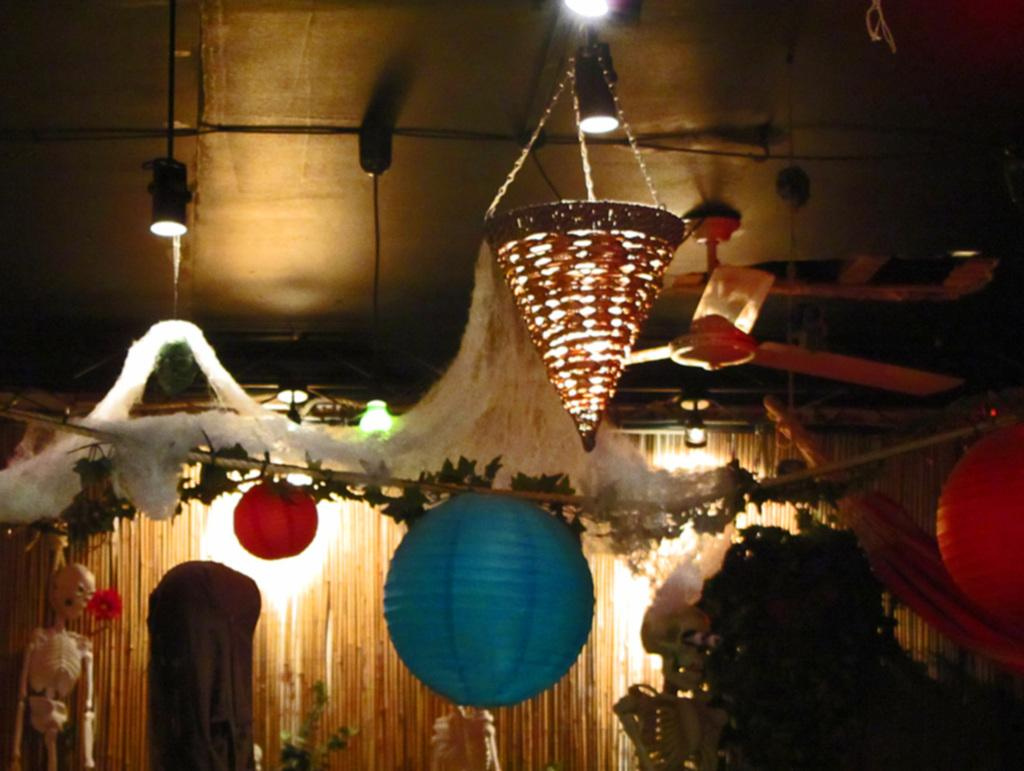What type of objects can be seen in the image? There are skeletons, balls, leaves, lights, and a fan in the image. What other unspecified objects are present in the image? There are other unspecified objects in the image. What can be seen in the background of the image? There is a wall in the background of the image. What type of island can be seen in the image? There is no island present in the image. What force is causing the skeletons to move in the image? The skeletons are not moving in the image, so there is no force causing them to move. 